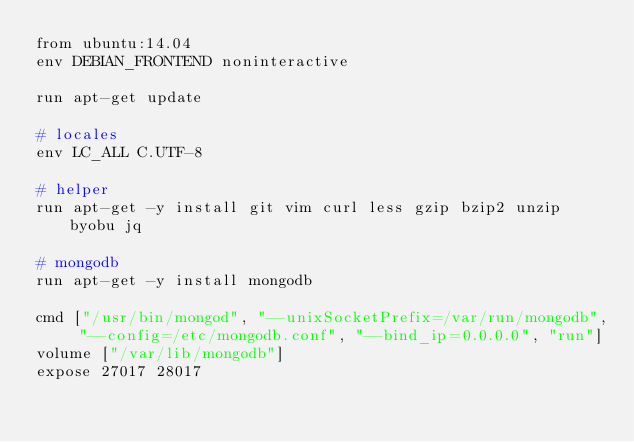<code> <loc_0><loc_0><loc_500><loc_500><_Dockerfile_>from ubuntu:14.04
env DEBIAN_FRONTEND noninteractive

run apt-get update

# locales
env LC_ALL C.UTF-8

# helper
run apt-get -y install git vim curl less gzip bzip2 unzip byobu jq

# mongodb
run apt-get -y install mongodb

cmd ["/usr/bin/mongod", "--unixSocketPrefix=/var/run/mongodb", "--config=/etc/mongodb.conf", "--bind_ip=0.0.0.0", "run"]
volume ["/var/lib/mongodb"]
expose 27017 28017</code> 